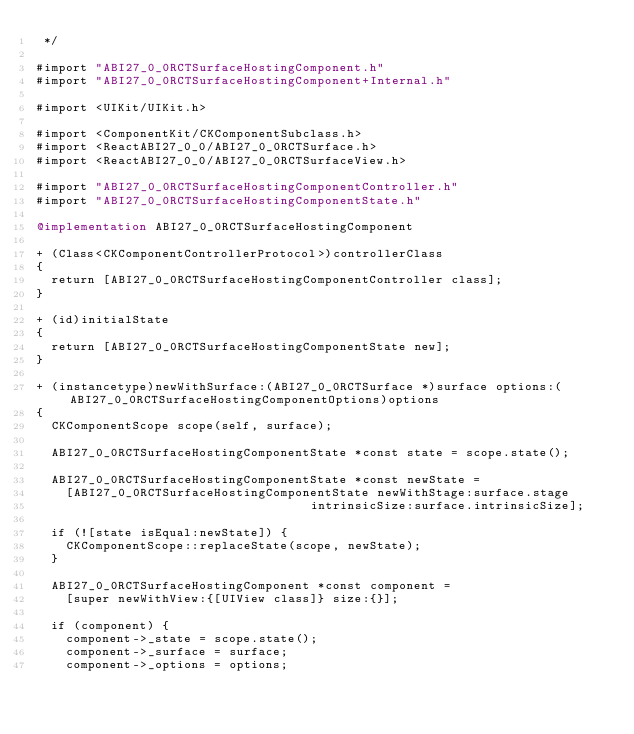<code> <loc_0><loc_0><loc_500><loc_500><_ObjectiveC_> */

#import "ABI27_0_0RCTSurfaceHostingComponent.h"
#import "ABI27_0_0RCTSurfaceHostingComponent+Internal.h"

#import <UIKit/UIKit.h>

#import <ComponentKit/CKComponentSubclass.h>
#import <ReactABI27_0_0/ABI27_0_0RCTSurface.h>
#import <ReactABI27_0_0/ABI27_0_0RCTSurfaceView.h>

#import "ABI27_0_0RCTSurfaceHostingComponentController.h"
#import "ABI27_0_0RCTSurfaceHostingComponentState.h"

@implementation ABI27_0_0RCTSurfaceHostingComponent

+ (Class<CKComponentControllerProtocol>)controllerClass
{
  return [ABI27_0_0RCTSurfaceHostingComponentController class];
}

+ (id)initialState
{
  return [ABI27_0_0RCTSurfaceHostingComponentState new];
}

+ (instancetype)newWithSurface:(ABI27_0_0RCTSurface *)surface options:(ABI27_0_0RCTSurfaceHostingComponentOptions)options
{
  CKComponentScope scope(self, surface);

  ABI27_0_0RCTSurfaceHostingComponentState *const state = scope.state();

  ABI27_0_0RCTSurfaceHostingComponentState *const newState =
    [ABI27_0_0RCTSurfaceHostingComponentState newWithStage:surface.stage
                                     intrinsicSize:surface.intrinsicSize];

  if (![state isEqual:newState]) {
    CKComponentScope::replaceState(scope, newState);
  }

  ABI27_0_0RCTSurfaceHostingComponent *const component =
    [super newWithView:{[UIView class]} size:{}];

  if (component) {
    component->_state = scope.state();
    component->_surface = surface;
    component->_options = options;</code> 